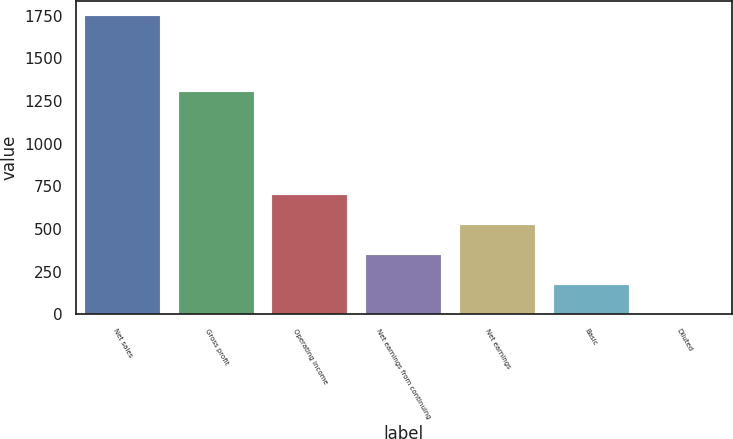Convert chart. <chart><loc_0><loc_0><loc_500><loc_500><bar_chart><fcel>Net sales<fcel>Gross profit<fcel>Operating income<fcel>Net earnings from continuing<fcel>Net earnings<fcel>Basic<fcel>Diluted<nl><fcel>1750.3<fcel>1302.3<fcel>700.48<fcel>350.54<fcel>525.51<fcel>175.57<fcel>0.6<nl></chart> 